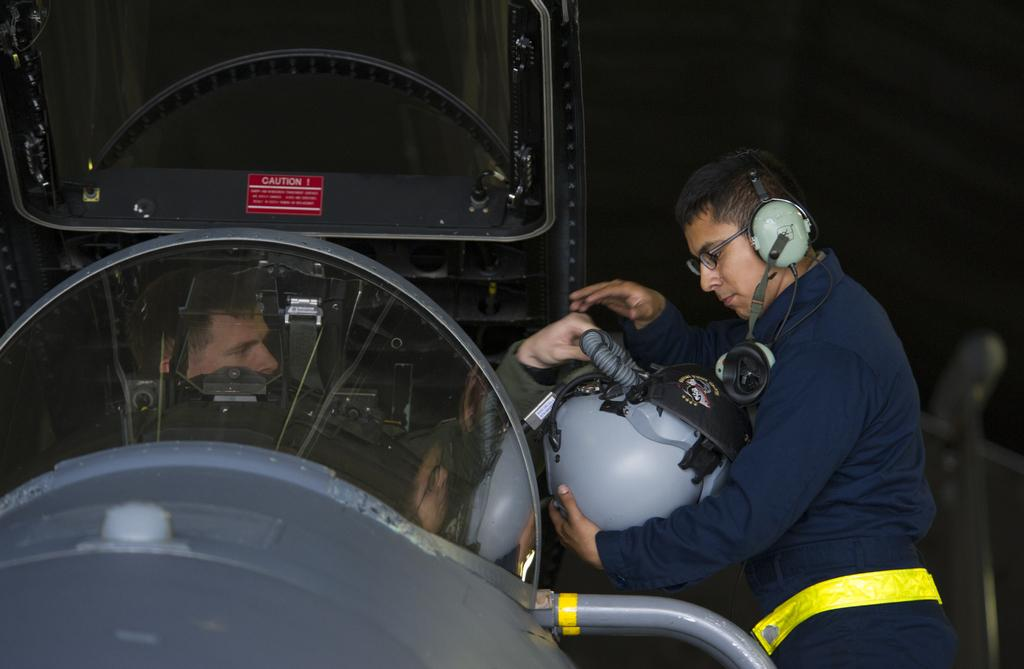What is the main subject of the image? The main subject of the image is a person sitting in a vehicle. Can you describe the person beside the vehicle? The person beside the vehicle is holding a helmet, wearing headphones, and wearing spectacles. What might the person beside the vehicle be preparing to do? The person beside the vehicle might be preparing to ride the vehicle, as they are holding a helmet. What date is circled on the calendar in the image? There is no calendar present in the image. How does the person sitting in the vehicle feel about the situation? The image does not provide any information about the person's feelings or emotions. 